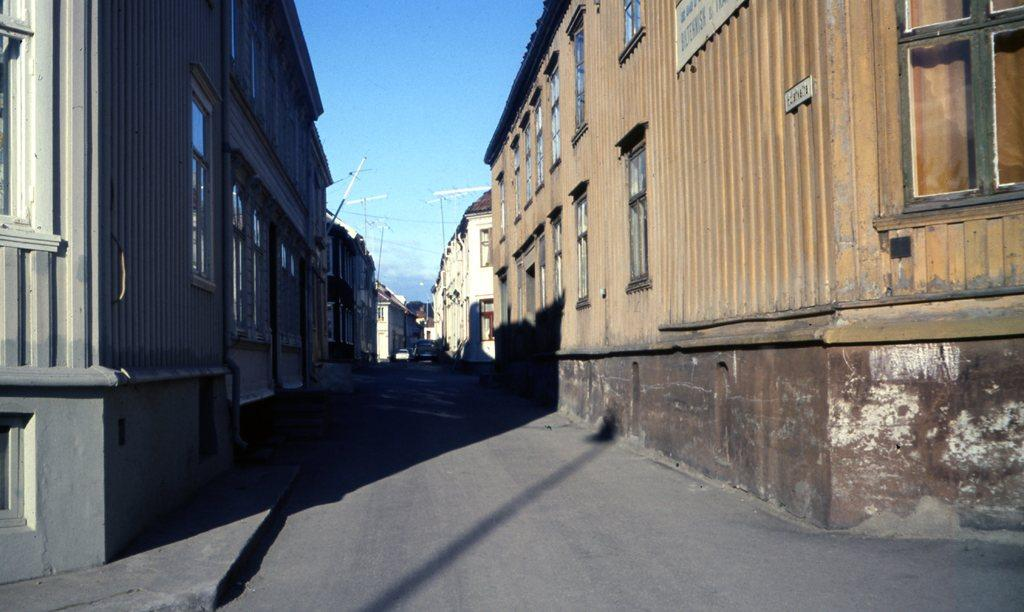What is the main feature of the image? There is a road in the image. Where is the road located in relation to the buildings? The road is between buildings. What colors are the buildings? The buildings are in brown and grey colors. What else can be seen on the road? There are vehicles on the road. What is visible at the top of the image? The sky is visible at the top of the image. Can you tell me how many doctors are walking under an umbrella in the image? There are no doctors or umbrellas present in the image; it features a road between buildings with vehicles on it. Is there an owl perched on top of one of the buildings in the image? There is no owl present in the image; it only features a road, buildings, and vehicles. 